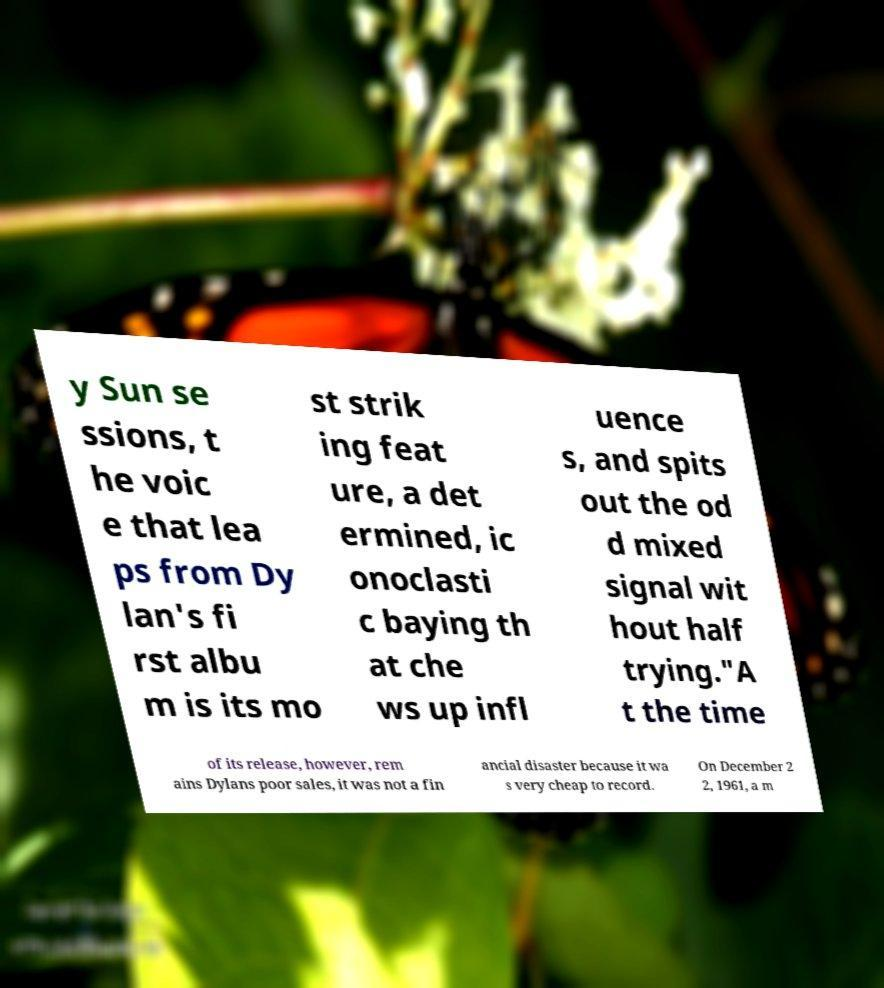Can you read and provide the text displayed in the image?This photo seems to have some interesting text. Can you extract and type it out for me? y Sun se ssions, t he voic e that lea ps from Dy lan's fi rst albu m is its mo st strik ing feat ure, a det ermined, ic onoclasti c baying th at che ws up infl uence s, and spits out the od d mixed signal wit hout half trying."A t the time of its release, however, rem ains Dylans poor sales, it was not a fin ancial disaster because it wa s very cheap to record. On December 2 2, 1961, a m 